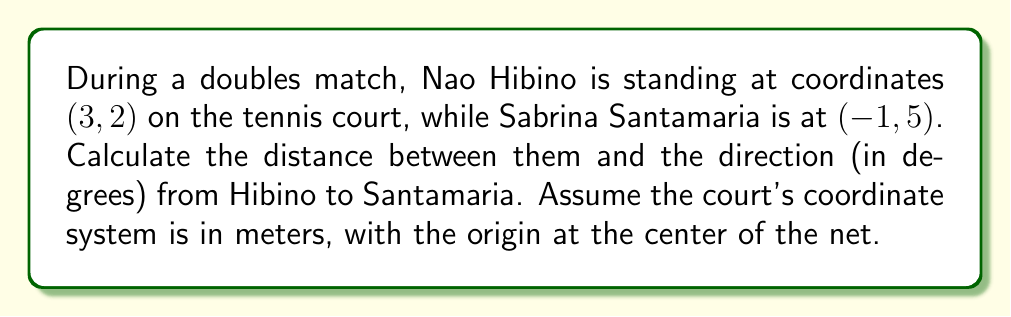Can you solve this math problem? Let's approach this step-by-step:

1) First, we need to find the vector from Hibino to Santamaria:
   $$\vec{v} = (x_2 - x_1, y_2 - y_1) = (-1 - 3, 5 - 2) = (-4, 3)$$

2) To calculate the distance, we use the magnitude of this vector:
   $$\text{distance} = \|\vec{v}\| = \sqrt{(-4)^2 + 3^2} = \sqrt{16 + 9} = \sqrt{25} = 5 \text{ meters}$$

3) For the direction, we need to find the angle this vector makes with the positive x-axis.
   We can use the arctangent function:
   $$\theta = \arctan(\frac{y}{x}) = \arctan(\frac{3}{-4})$$

4) However, we need to be careful here. The arctangent function only gives values from -90° to 90°.
   Since our x is negative and y is positive, we're in the second quadrant.
   We need to add 180° to the result:

   $$\theta = \arctan(\frac{3}{-4}) + 180° = -36.87° + 180° = 143.13°$$

5) To get this in degrees from the positive x-axis (counterclockwise), we subtract from 360°:
   $$\text{direction} = 360° - 143.13° = 216.87°$$

[asy]
unitsize(20);
draw((-5,-5)--(5,5), arrow=Arrow(TeXHead));
draw((-5,0)--(5,0), arrow=Arrow(TeXHead));
draw((0,-5)--(0,5), arrow=Arrow(TeXHead));
dot((3,2));
dot((-1,5));
draw((3,2)--(-1,5), arrow=Arrow(TeXHead));
label("Hibino (3,2)", (3,2), SE);
label("Santamaria (-1,5)", (-1,5), NW);
label("x", (5,0), E);
label("y", (0,5), N);
[/asy]
Answer: Distance: 5 meters, Direction: 216.87° 